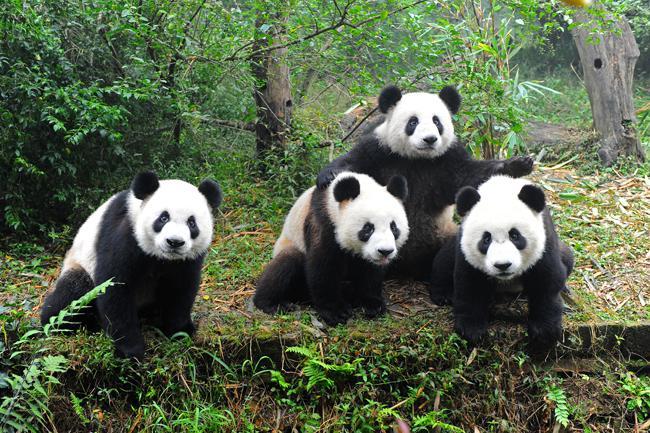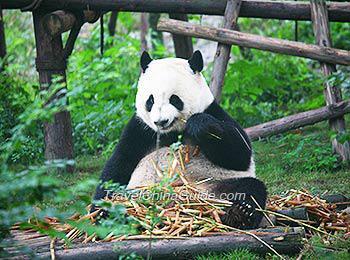The first image is the image on the left, the second image is the image on the right. Assess this claim about the two images: "An image shows multiple pandas sitting among foliage and chewing on stalks.". Correct or not? Answer yes or no. No. The first image is the image on the left, the second image is the image on the right. Considering the images on both sides, is "In one of the images there are three panda sitting and eating bamboo." valid? Answer yes or no. No. 